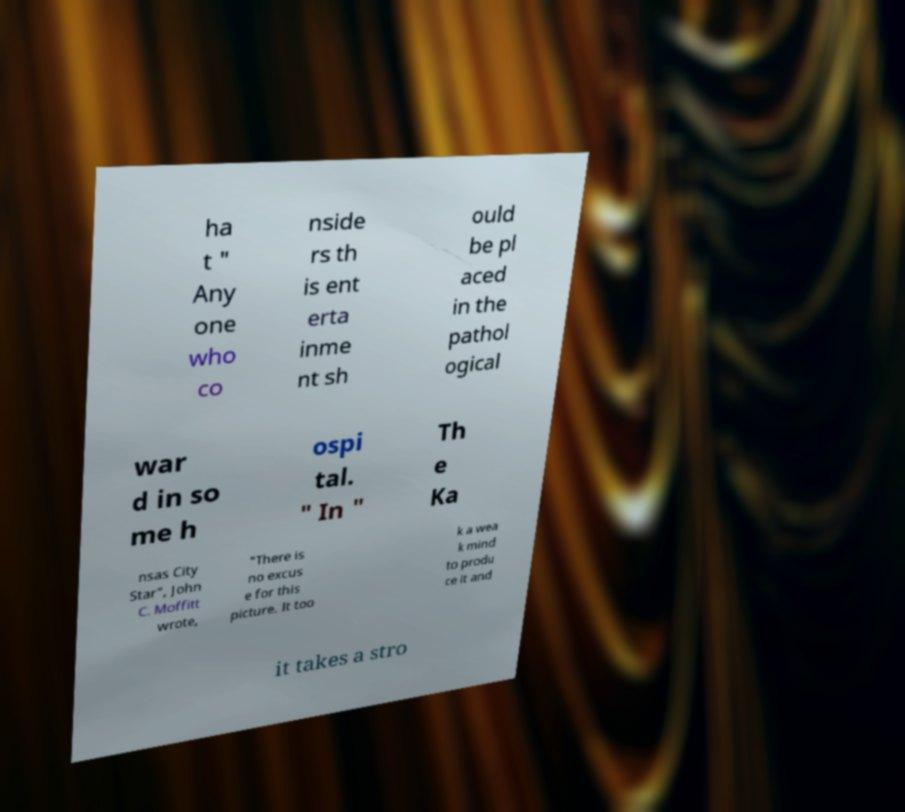Could you extract and type out the text from this image? ha t " Any one who co nside rs th is ent erta inme nt sh ould be pl aced in the pathol ogical war d in so me h ospi tal. " In " Th e Ka nsas City Star", John C. Moffitt wrote, "There is no excus e for this picture. It too k a wea k mind to produ ce it and it takes a stro 